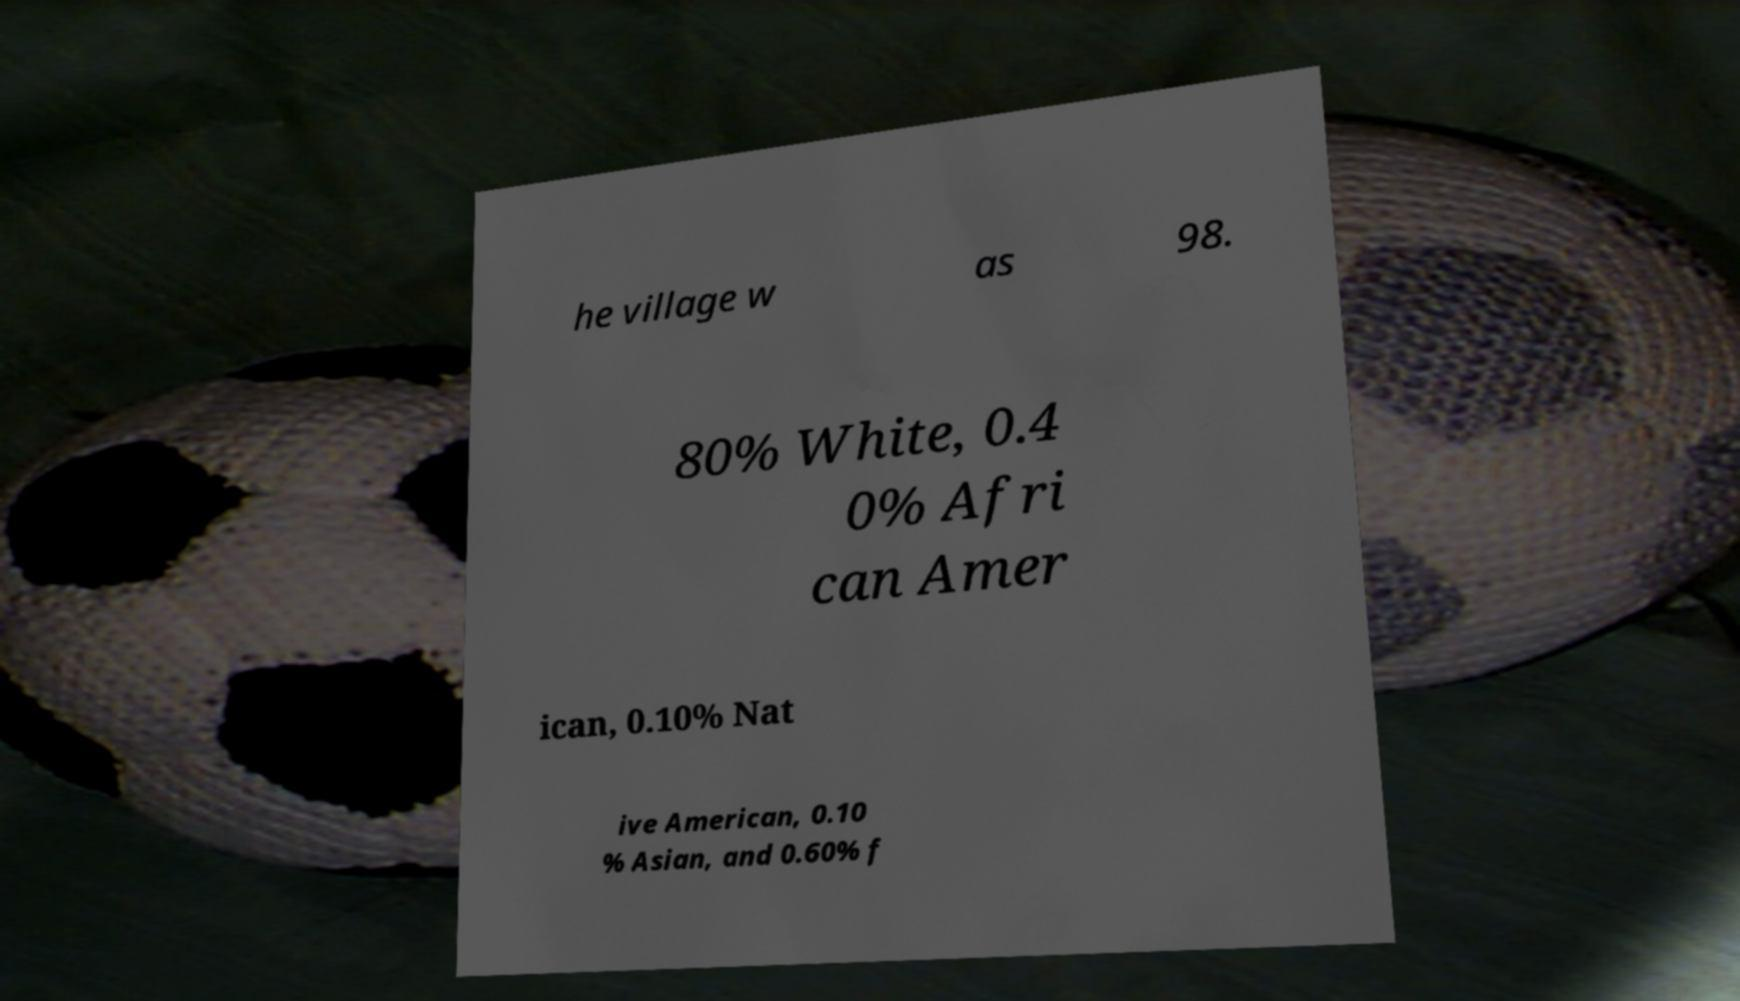Could you assist in decoding the text presented in this image and type it out clearly? he village w as 98. 80% White, 0.4 0% Afri can Amer ican, 0.10% Nat ive American, 0.10 % Asian, and 0.60% f 